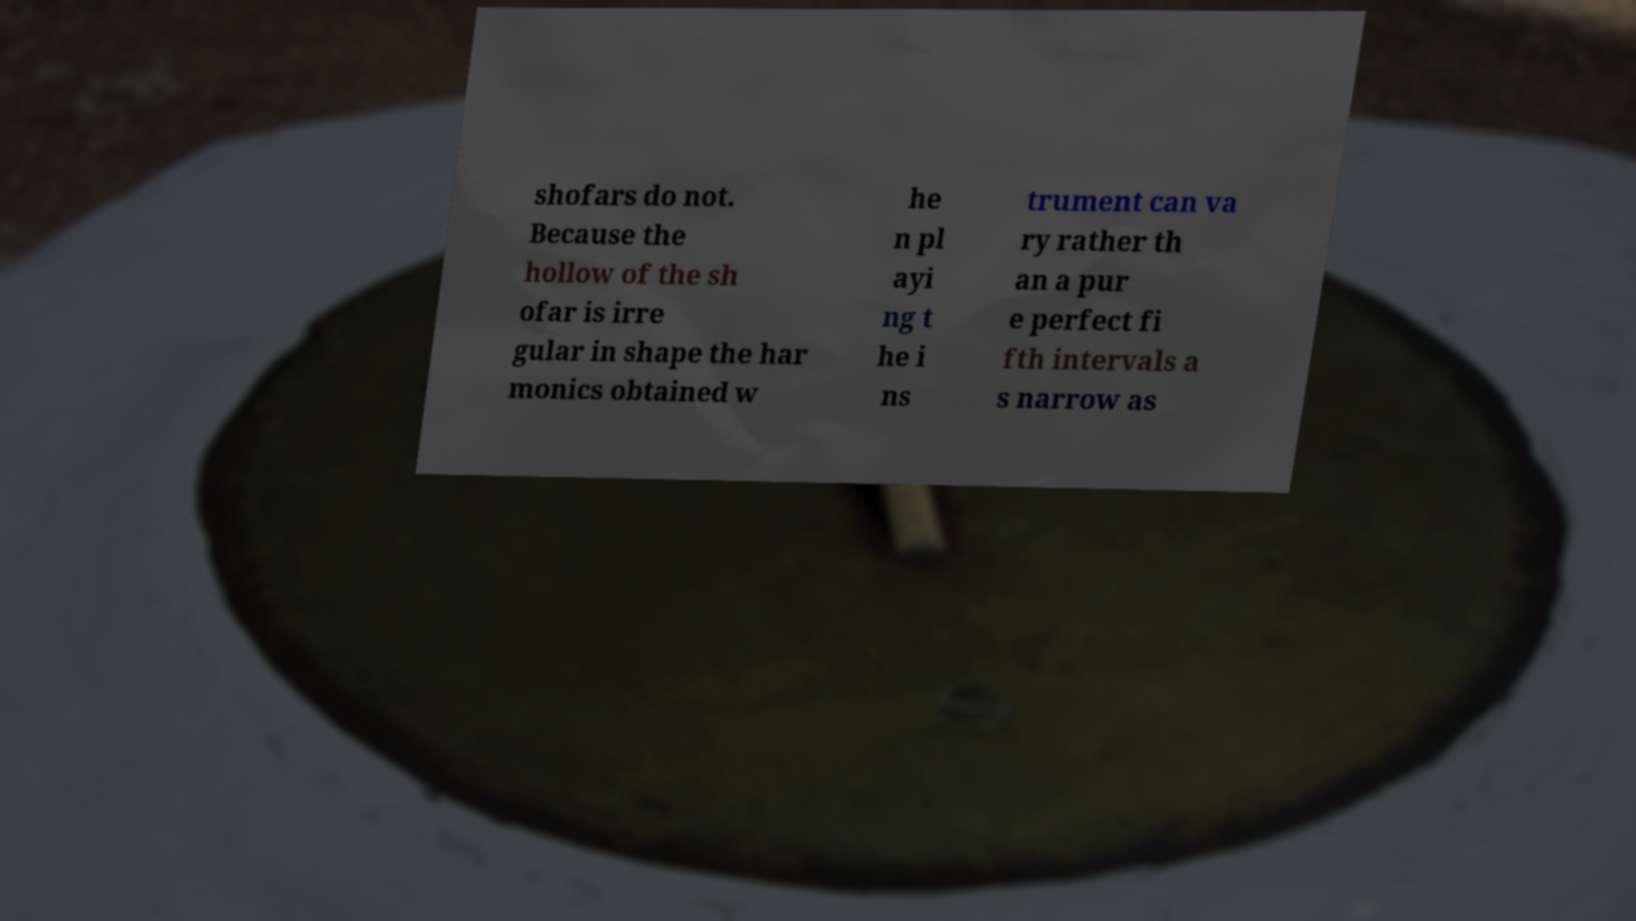Could you extract and type out the text from this image? shofars do not. Because the hollow of the sh ofar is irre gular in shape the har monics obtained w he n pl ayi ng t he i ns trument can va ry rather th an a pur e perfect fi fth intervals a s narrow as 